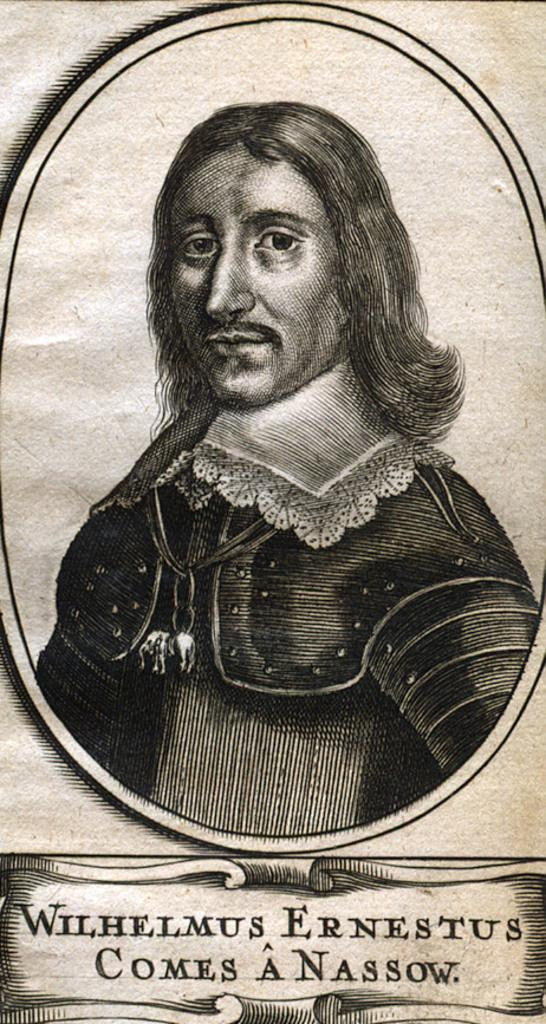What is the main subject in the foreground of the image? There is a man in the foreground of the image. Can you describe any text that is visible in the image? Yes, there is some text at the bottom of the image. What type of smile can be seen on the man's face in the image? There is no indication of a smile on the man's face in the image. What belief system does the text at the bottom of the image represent? The provided facts do not give any information about the content or meaning of the text at the bottom of the image, so it is not possible to determine the belief system it represents. How many verses are present in the image? There is no mention of verses in the provided facts, so it is not possible to determine the number of verses present in the image. 